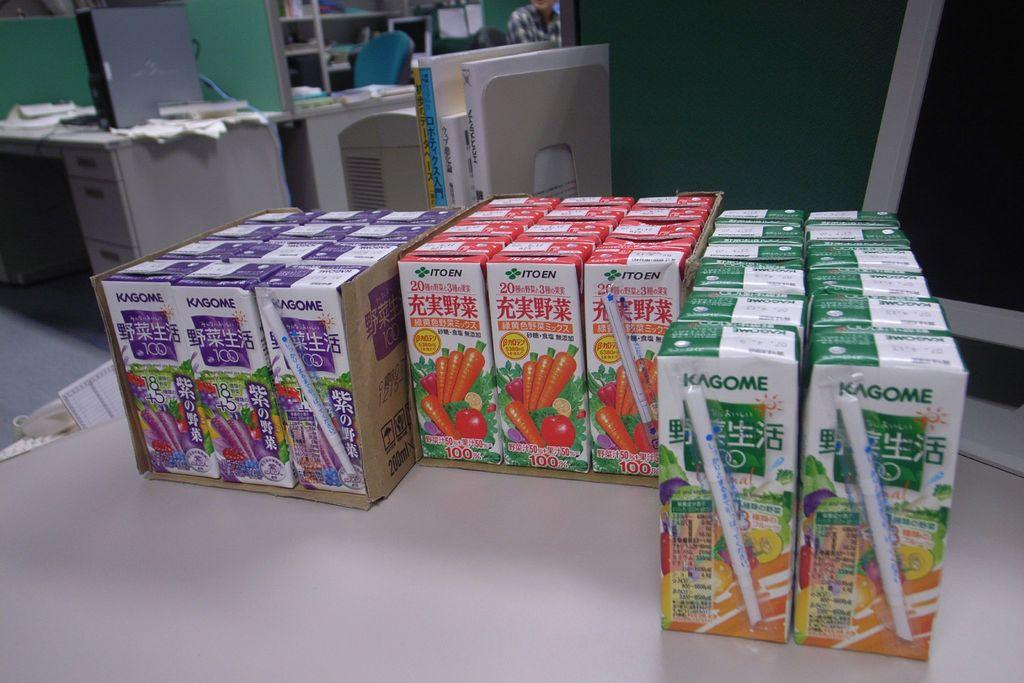<image>
Describe the image concisely. Several packs of various flavours of Kagome juice sit on an office table. 